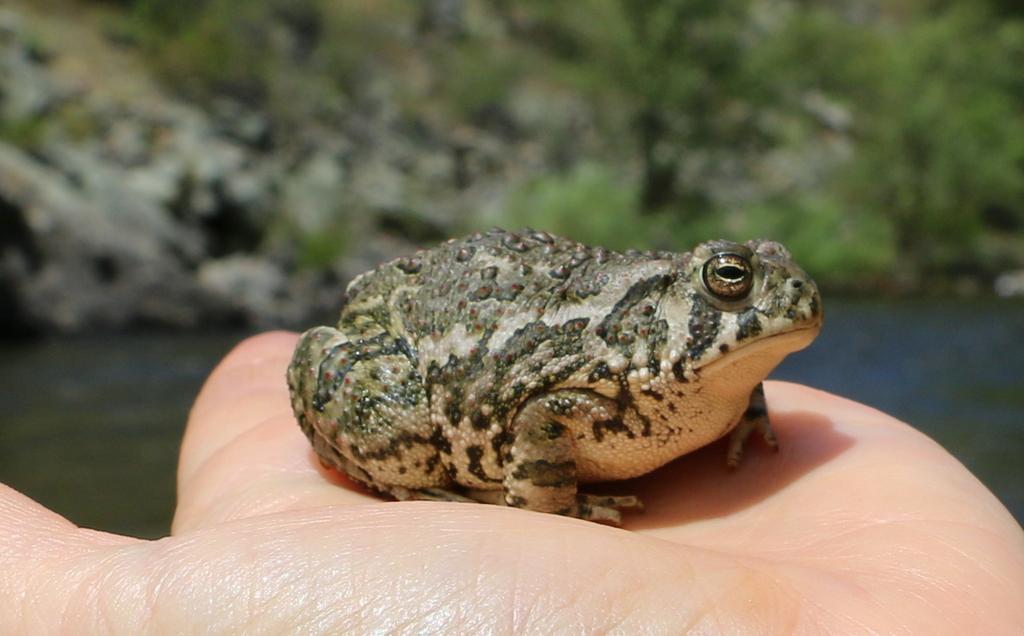Describe this image in one or two sentences. In the center of the image, we can see a frog on a person's hand and in the background, there are hills, trees and there is a water. 